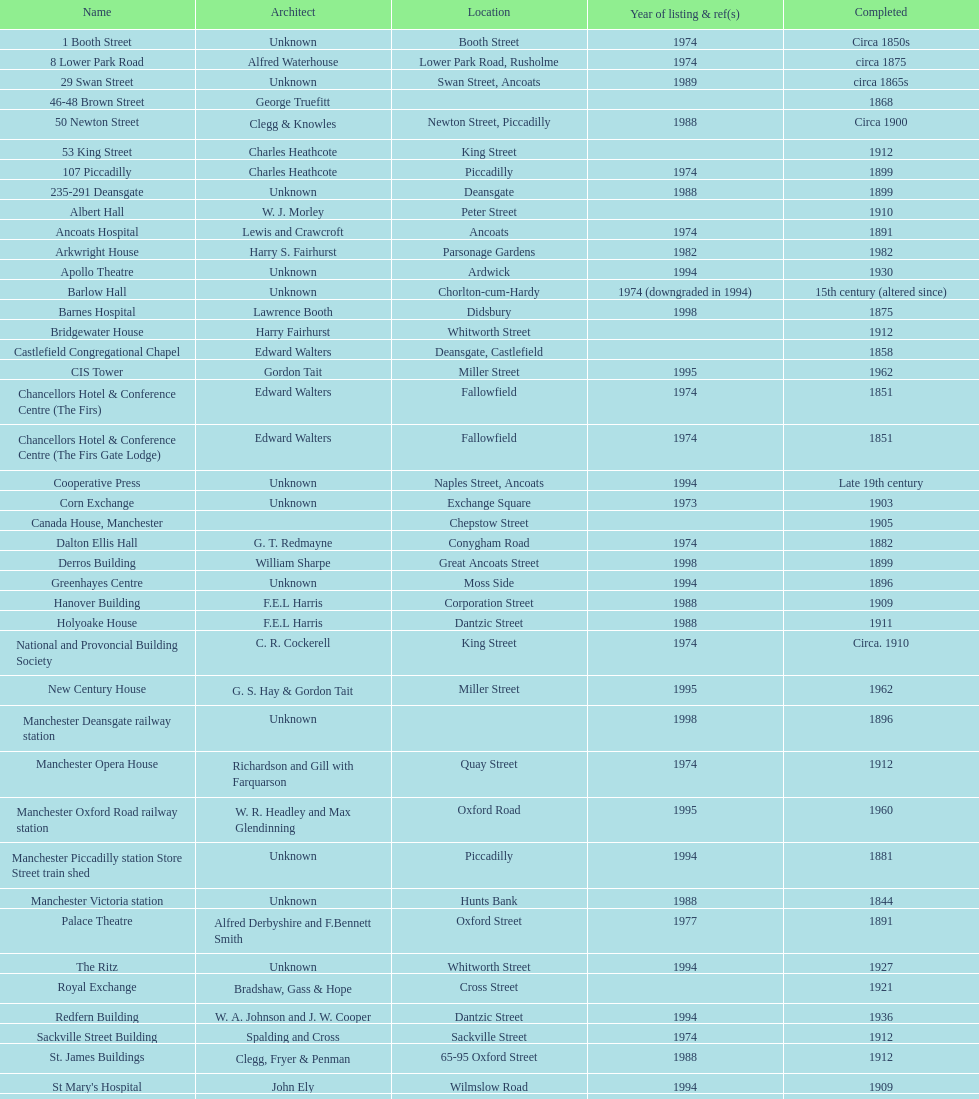Parse the full table. {'header': ['Name', 'Architect', 'Location', 'Year of listing & ref(s)', 'Completed'], 'rows': [['1 Booth Street', 'Unknown', 'Booth Street', '1974', 'Circa 1850s'], ['8 Lower Park Road', 'Alfred Waterhouse', 'Lower Park Road, Rusholme', '1974', 'circa 1875'], ['29 Swan Street', 'Unknown', 'Swan Street, Ancoats', '1989', 'circa 1865s'], ['46-48 Brown Street', 'George Truefitt', '', '', '1868'], ['50 Newton Street', 'Clegg & Knowles', 'Newton Street, Piccadilly', '1988', 'Circa 1900'], ['53 King Street', 'Charles Heathcote', 'King Street', '', '1912'], ['107 Piccadilly', 'Charles Heathcote', 'Piccadilly', '1974', '1899'], ['235-291 Deansgate', 'Unknown', 'Deansgate', '1988', '1899'], ['Albert Hall', 'W. J. Morley', 'Peter Street', '', '1910'], ['Ancoats Hospital', 'Lewis and Crawcroft', 'Ancoats', '1974', '1891'], ['Arkwright House', 'Harry S. Fairhurst', 'Parsonage Gardens', '1982', '1982'], ['Apollo Theatre', 'Unknown', 'Ardwick', '1994', '1930'], ['Barlow Hall', 'Unknown', 'Chorlton-cum-Hardy', '1974 (downgraded in 1994)', '15th century (altered since)'], ['Barnes Hospital', 'Lawrence Booth', 'Didsbury', '1998', '1875'], ['Bridgewater House', 'Harry Fairhurst', 'Whitworth Street', '', '1912'], ['Castlefield Congregational Chapel', 'Edward Walters', 'Deansgate, Castlefield', '', '1858'], ['CIS Tower', 'Gordon Tait', 'Miller Street', '1995', '1962'], ['Chancellors Hotel & Conference Centre (The Firs)', 'Edward Walters', 'Fallowfield', '1974', '1851'], ['Chancellors Hotel & Conference Centre (The Firs Gate Lodge)', 'Edward Walters', 'Fallowfield', '1974', '1851'], ['Cooperative Press', 'Unknown', 'Naples Street, Ancoats', '1994', 'Late 19th century'], ['Corn Exchange', 'Unknown', 'Exchange Square', '1973', '1903'], ['Canada House, Manchester', '', 'Chepstow Street', '', '1905'], ['Dalton Ellis Hall', 'G. T. Redmayne', 'Conygham Road', '1974', '1882'], ['Derros Building', 'William Sharpe', 'Great Ancoats Street', '1998', '1899'], ['Greenhayes Centre', 'Unknown', 'Moss Side', '1994', '1896'], ['Hanover Building', 'F.E.L Harris', 'Corporation Street', '1988', '1909'], ['Holyoake House', 'F.E.L Harris', 'Dantzic Street', '1988', '1911'], ['National and Provoncial Building Society', 'C. R. Cockerell', 'King Street', '1974', 'Circa. 1910'], ['New Century House', 'G. S. Hay & Gordon Tait', 'Miller Street', '1995', '1962'], ['Manchester Deansgate railway station', 'Unknown', '', '1998', '1896'], ['Manchester Opera House', 'Richardson and Gill with Farquarson', 'Quay Street', '1974', '1912'], ['Manchester Oxford Road railway station', 'W. R. Headley and Max Glendinning', 'Oxford Road', '1995', '1960'], ['Manchester Piccadilly station Store Street train shed', 'Unknown', 'Piccadilly', '1994', '1881'], ['Manchester Victoria station', 'Unknown', 'Hunts Bank', '1988', '1844'], ['Palace Theatre', 'Alfred Derbyshire and F.Bennett Smith', 'Oxford Street', '1977', '1891'], ['The Ritz', 'Unknown', 'Whitworth Street', '1994', '1927'], ['Royal Exchange', 'Bradshaw, Gass & Hope', 'Cross Street', '', '1921'], ['Redfern Building', 'W. A. Johnson and J. W. Cooper', 'Dantzic Street', '1994', '1936'], ['Sackville Street Building', 'Spalding and Cross', 'Sackville Street', '1974', '1912'], ['St. James Buildings', 'Clegg, Fryer & Penman', '65-95 Oxford Street', '1988', '1912'], ["St Mary's Hospital", 'John Ely', 'Wilmslow Road', '1994', '1909'], ['Samuel Alexander Building', 'Percy Scott Worthington', 'Oxford Road', '2010', '1919'], ['Ship Canal House', 'Harry S. Fairhurst', 'King Street', '1982', '1927'], ['Smithfield Market Hall', 'Unknown', 'Swan Street, Ancoats', '1973', '1857'], ['Strangeways Gaol Gatehouse', 'Alfred Waterhouse', 'Sherborne Street', '1974', '1868'], ['Strangeways Prison ventilation and watch tower', 'Alfred Waterhouse', 'Sherborne Street', '1974', '1868'], ['Theatre Royal', 'Irwin and Chester', 'Peter Street', '1974', '1845'], ['Toast Rack', 'L. C. Howitt', 'Fallowfield', '1999', '1960'], ['The Old Wellington Inn', 'Unknown', 'Shambles Square', '1952', 'Mid-16th century'], ['Whitworth Park Mansions', 'Unknown', 'Whitworth Park', '1974', 'Circa 1840s']]} How many buildings has the same year of listing as 1974? 15. 